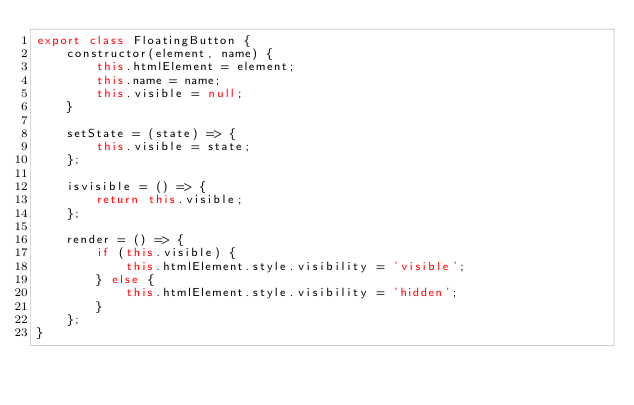<code> <loc_0><loc_0><loc_500><loc_500><_JavaScript_>export class FloatingButton {
    constructor(element, name) {
        this.htmlElement = element;
        this.name = name;
        this.visible = null;
    }

    setState = (state) => {
        this.visible = state;
    };

    isvisible = () => {
        return this.visible;
    };

    render = () => {
        if (this.visible) {
            this.htmlElement.style.visibility = 'visible';
        } else {
            this.htmlElement.style.visibility = 'hidden';
        }
    };
}</code> 